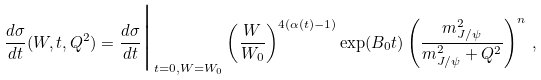<formula> <loc_0><loc_0><loc_500><loc_500>\frac { d \sigma } { d t } ( W , t , Q ^ { 2 } ) = \frac { d \sigma } { d t } \Big | _ { t = 0 , W = W _ { 0 } } \left ( \frac { W } { W _ { 0 } } \right ) ^ { 4 ( \alpha ( t ) - 1 ) } \exp ( B _ { 0 } t ) \left ( \frac { m _ { J / \psi } ^ { 2 } } { m _ { J / \psi } ^ { 2 } + Q ^ { 2 } } \right ) ^ { n } \, ,</formula> 